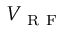Convert formula to latex. <formula><loc_0><loc_0><loc_500><loc_500>V _ { R F }</formula> 